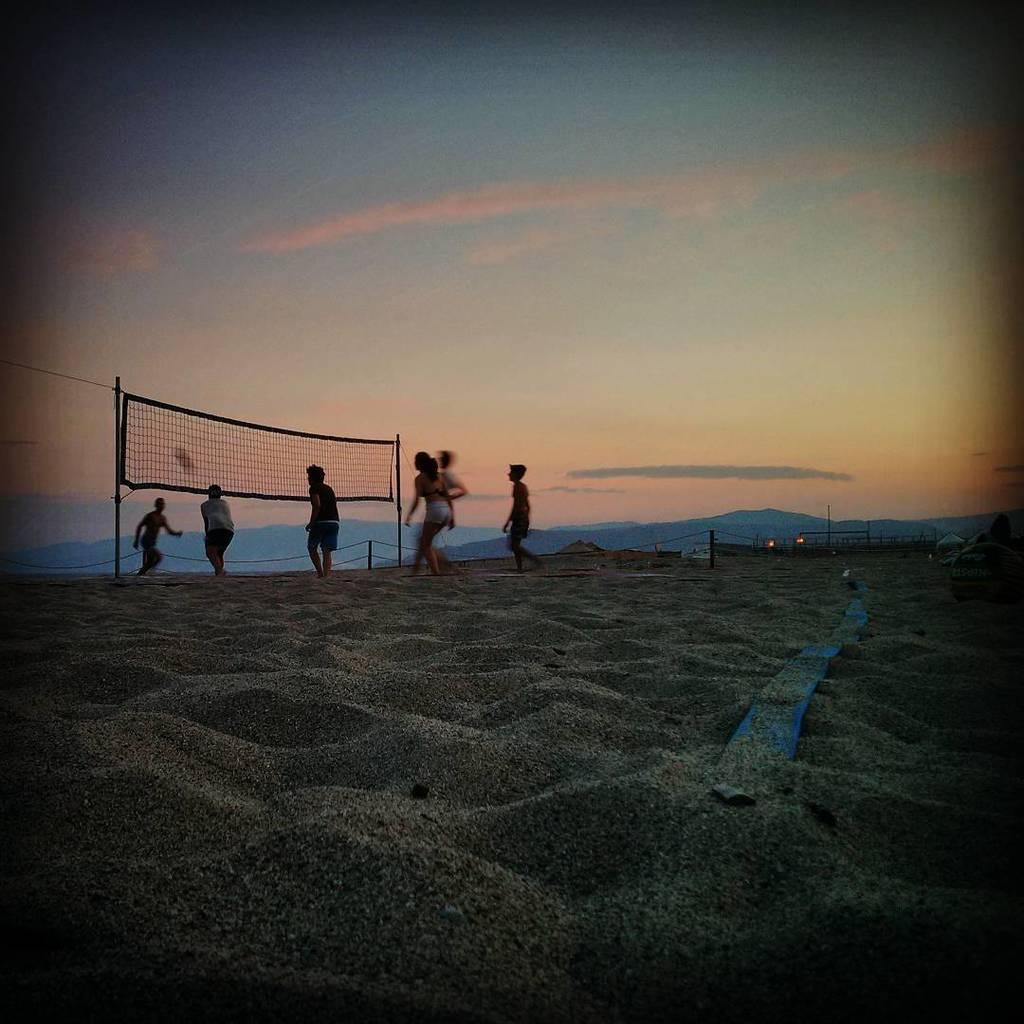What type of surface is visible in the image? There is sand in the image. What are the people in the image doing? The people are standing and playing a game. What objects are involved in the game being played? There is a ball and a net in the image. What structures are present in the image? There are poles in the image. What can be seen in the background of the image? There are hills and the sky visible in the image. What type of sign can be seen in the image? There is no sign present in the image. How are the people in the image connected to each other? The image does not show any connections between the people; they are simply standing and playing a game. 